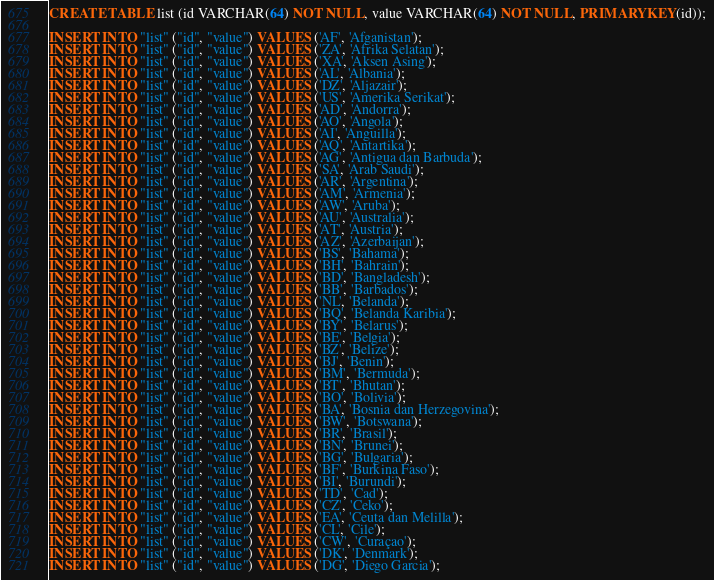Convert code to text. <code><loc_0><loc_0><loc_500><loc_500><_SQL_>CREATE TABLE list (id VARCHAR(64) NOT NULL, value VARCHAR(64) NOT NULL, PRIMARY KEY(id));

INSERT INTO "list" ("id", "value") VALUES ('AF', 'Afganistan');
INSERT INTO "list" ("id", "value") VALUES ('ZA', 'Afrika Selatan');
INSERT INTO "list" ("id", "value") VALUES ('XA', 'Aksen Asing');
INSERT INTO "list" ("id", "value") VALUES ('AL', 'Albania');
INSERT INTO "list" ("id", "value") VALUES ('DZ', 'Aljazair');
INSERT INTO "list" ("id", "value") VALUES ('US', 'Amerika Serikat');
INSERT INTO "list" ("id", "value") VALUES ('AD', 'Andorra');
INSERT INTO "list" ("id", "value") VALUES ('AO', 'Angola');
INSERT INTO "list" ("id", "value") VALUES ('AI', 'Anguilla');
INSERT INTO "list" ("id", "value") VALUES ('AQ', 'Antartika');
INSERT INTO "list" ("id", "value") VALUES ('AG', 'Antigua dan Barbuda');
INSERT INTO "list" ("id", "value") VALUES ('SA', 'Arab Saudi');
INSERT INTO "list" ("id", "value") VALUES ('AR', 'Argentina');
INSERT INTO "list" ("id", "value") VALUES ('AM', 'Armenia');
INSERT INTO "list" ("id", "value") VALUES ('AW', 'Aruba');
INSERT INTO "list" ("id", "value") VALUES ('AU', 'Australia');
INSERT INTO "list" ("id", "value") VALUES ('AT', 'Austria');
INSERT INTO "list" ("id", "value") VALUES ('AZ', 'Azerbaijan');
INSERT INTO "list" ("id", "value") VALUES ('BS', 'Bahama');
INSERT INTO "list" ("id", "value") VALUES ('BH', 'Bahrain');
INSERT INTO "list" ("id", "value") VALUES ('BD', 'Bangladesh');
INSERT INTO "list" ("id", "value") VALUES ('BB', 'Barbados');
INSERT INTO "list" ("id", "value") VALUES ('NL', 'Belanda');
INSERT INTO "list" ("id", "value") VALUES ('BQ', 'Belanda Karibia');
INSERT INTO "list" ("id", "value") VALUES ('BY', 'Belarus');
INSERT INTO "list" ("id", "value") VALUES ('BE', 'Belgia');
INSERT INTO "list" ("id", "value") VALUES ('BZ', 'Belize');
INSERT INTO "list" ("id", "value") VALUES ('BJ', 'Benin');
INSERT INTO "list" ("id", "value") VALUES ('BM', 'Bermuda');
INSERT INTO "list" ("id", "value") VALUES ('BT', 'Bhutan');
INSERT INTO "list" ("id", "value") VALUES ('BO', 'Bolivia');
INSERT INTO "list" ("id", "value") VALUES ('BA', 'Bosnia dan Herzegovina');
INSERT INTO "list" ("id", "value") VALUES ('BW', 'Botswana');
INSERT INTO "list" ("id", "value") VALUES ('BR', 'Brasil');
INSERT INTO "list" ("id", "value") VALUES ('BN', 'Brunei');
INSERT INTO "list" ("id", "value") VALUES ('BG', 'Bulgaria');
INSERT INTO "list" ("id", "value") VALUES ('BF', 'Burkina Faso');
INSERT INTO "list" ("id", "value") VALUES ('BI', 'Burundi');
INSERT INTO "list" ("id", "value") VALUES ('TD', 'Cad');
INSERT INTO "list" ("id", "value") VALUES ('CZ', 'Ceko');
INSERT INTO "list" ("id", "value") VALUES ('EA', 'Ceuta dan Melilla');
INSERT INTO "list" ("id", "value") VALUES ('CL', 'Cile');
INSERT INTO "list" ("id", "value") VALUES ('CW', 'Curaçao');
INSERT INTO "list" ("id", "value") VALUES ('DK', 'Denmark');
INSERT INTO "list" ("id", "value") VALUES ('DG', 'Diego Garcia');</code> 